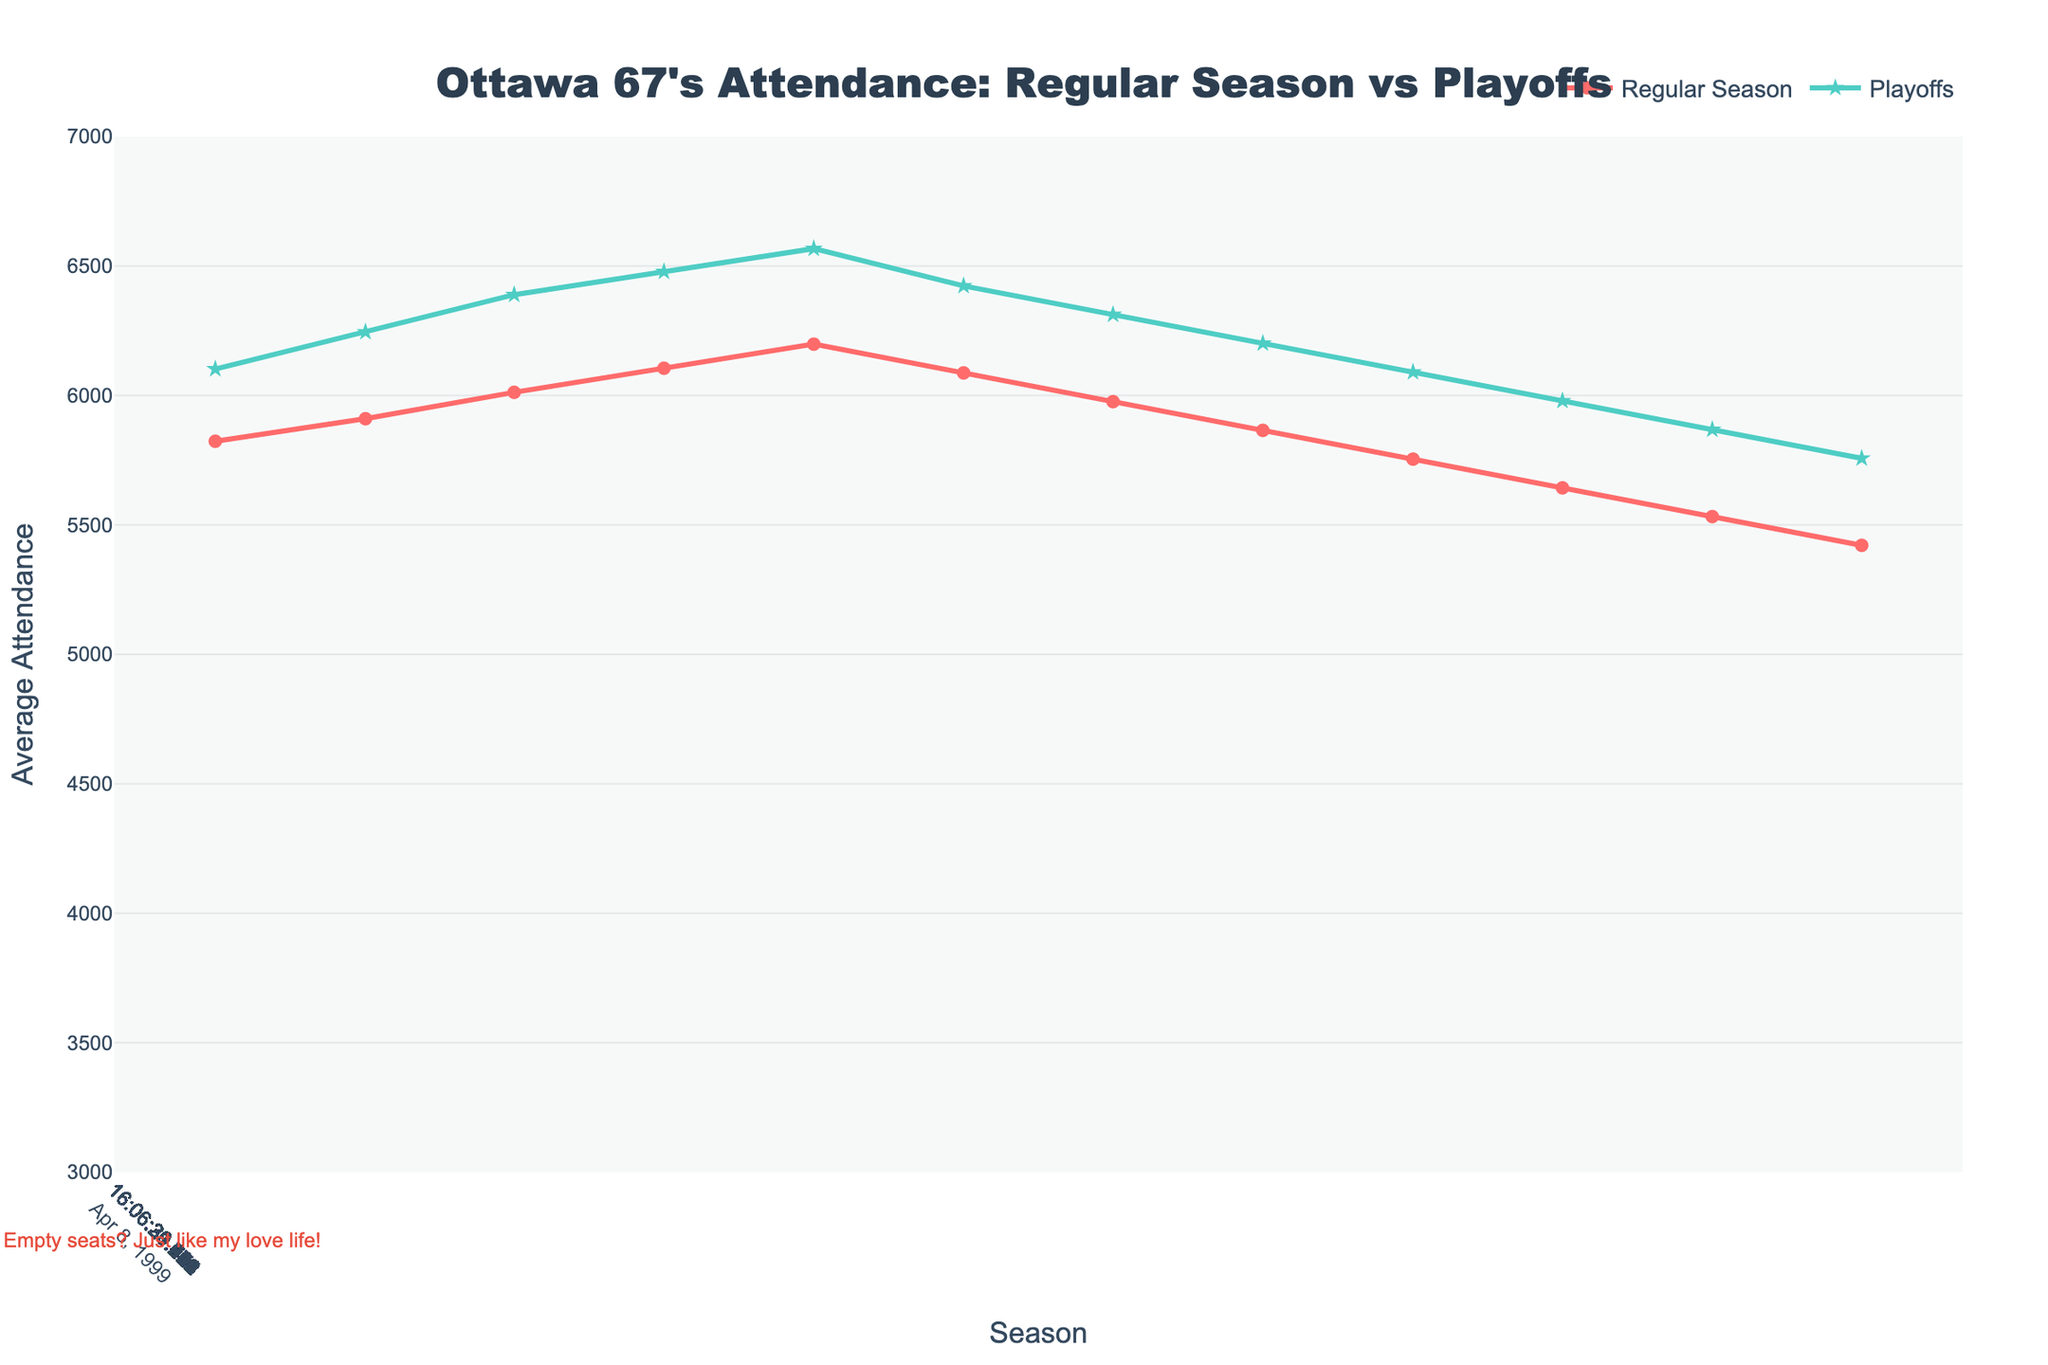What was the average regular season attendance during the 2005-06 season? The figure shows the regular season attendance values for each season. For the 2005-06 season, the value indicated is 6087.
Answer: 6087 Compare the average attendance between regular season and playoffs during the 2003-04 season. For the 2003-04 season, the regular season attendance is 6105 and the playoff attendance is 6478. Therefore, the playoff attendance is greater than the regular season attendance.
Answer: Playoffs Which season had the highest regular season attendance? Observing the regular season attendance trend, the highest point is at the 2004-05 season with 6198.
Answer: 2004-05 By how much did the average regular season attendance decrease from 2000-01 to 2018-19? For the 2000-01 season, the regular season attendance is 5823. For 2018-19, it's 4644. The decrease is 5823 - 4644 = 1179.
Answer: 1179 What is the color used for the playoff attendance line in the figure? The visual representation shows the playoff attendance line colored in green.
Answer: Green During the 2021-22 season, how did the average playoff attendance compare to the average regular season attendance? The figure indicates that for the 2021-22 season, the regular season attendance was 3500, and the playoff attendance was 3850, meaning the playoff attendance was higher.
Answer: Playoff attendance is higher Calculate the average playoff attendance over the entire period from 2000-01 to 2022-23, excluding the seasons with no data. Sum all provided playoff attendance values, excluding missing data: (6102 + 6245 + 6389 + 6478 + 6567 + 6423 + 6312 + 6201 + 6090 + 5979 + 5868 + 5757 + 5646 + 5535 + 5424 + 5313 + 5202 + 5091 + 4980 + 3850 + 4125) which equals 103012. Divide by the number of seasons with data (21), which gives 103012 / 21 = 4905.33.
Answer: 4905.33 Compare the regular season attendance trends before and after the 2019-20 season. Before the 2019-20 season, there is a general declining trend. After resuming in the 2021-22 season, there is an increase in average attendance until 2022-23.
Answer: Increasing after 2021-22 How did the regular season attendance change from 2000-01 to 2008-09? The regular season attendance in 2000-01 was 5823, and it decreased consistently to 5754 by the 2008-09 season. There's a downward trend noted.
Answer: Decreased During which season did both regular and playoff attendance hit their lowest points? Both the regular and playoff attendance hit their lowest points during the 2021-22 season, with 3500 and 3850 respectively.
Answer: 2021-22 